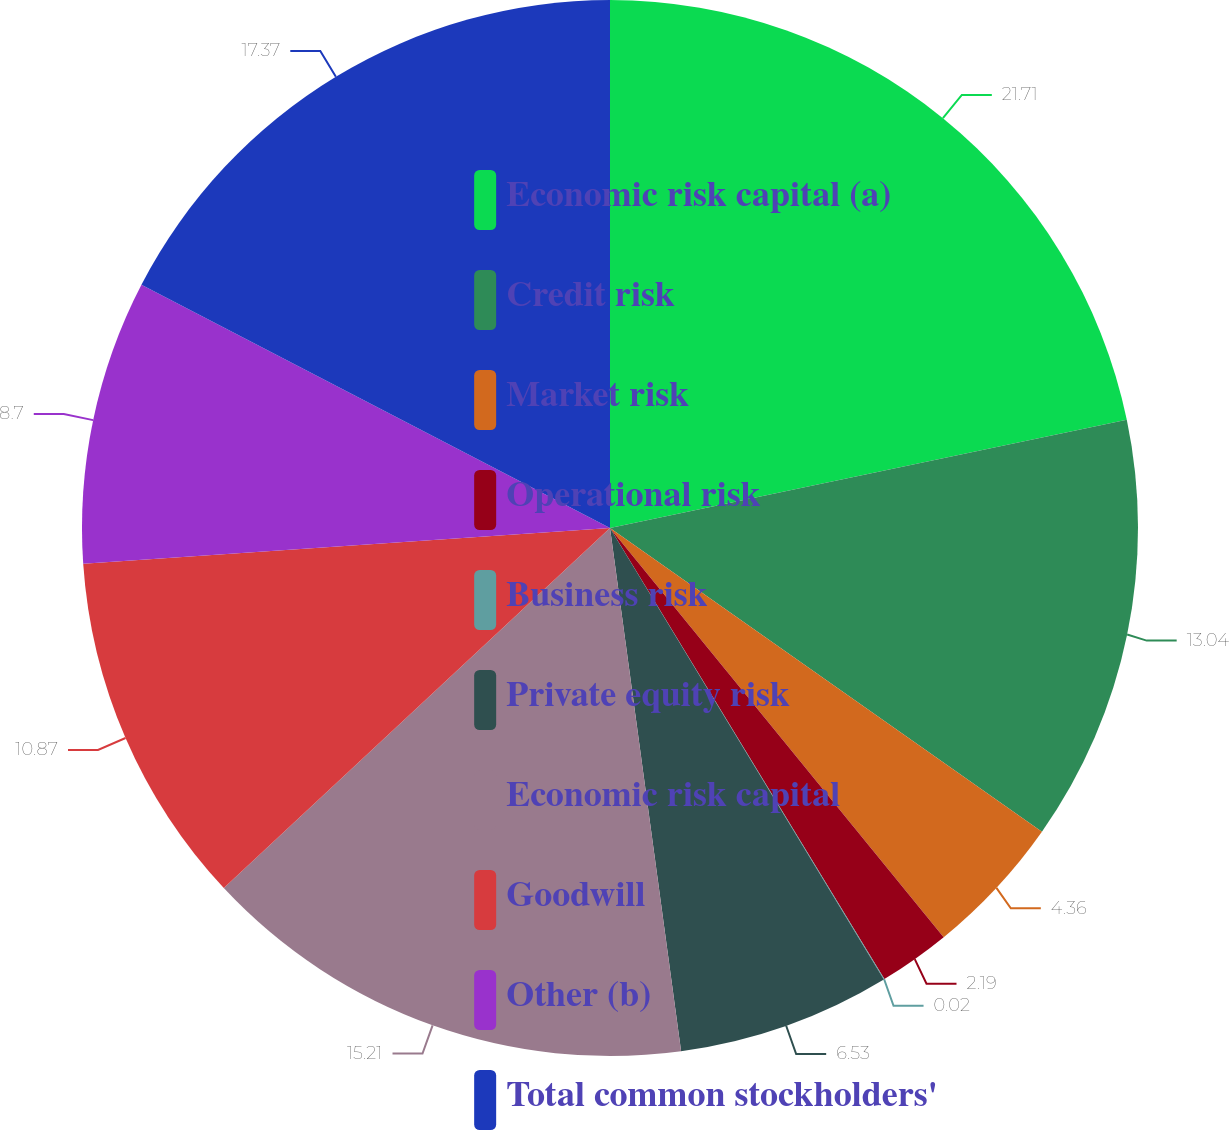Convert chart to OTSL. <chart><loc_0><loc_0><loc_500><loc_500><pie_chart><fcel>Economic risk capital (a)<fcel>Credit risk<fcel>Market risk<fcel>Operational risk<fcel>Business risk<fcel>Private equity risk<fcel>Economic risk capital<fcel>Goodwill<fcel>Other (b)<fcel>Total common stockholders'<nl><fcel>21.72%<fcel>13.04%<fcel>4.36%<fcel>2.19%<fcel>0.02%<fcel>6.53%<fcel>15.21%<fcel>10.87%<fcel>8.7%<fcel>17.38%<nl></chart> 